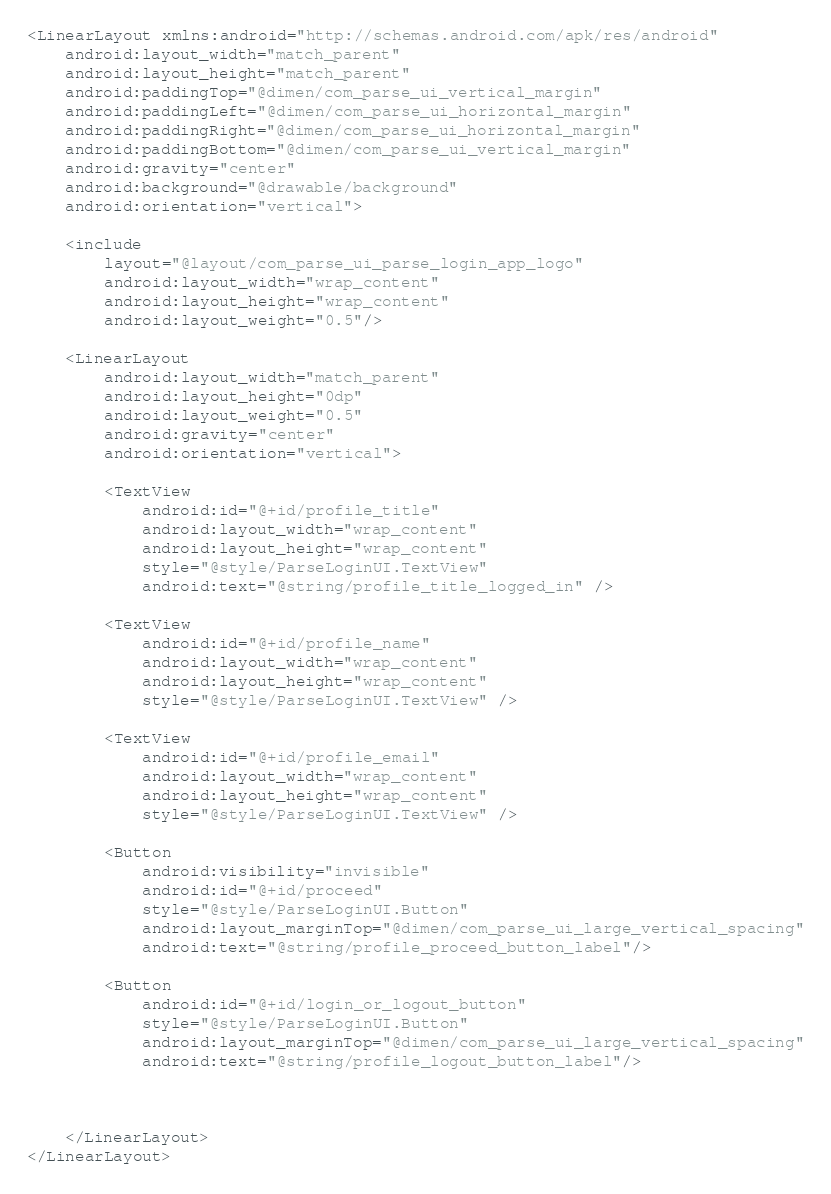Convert code to text. <code><loc_0><loc_0><loc_500><loc_500><_XML_><LinearLayout xmlns:android="http://schemas.android.com/apk/res/android"
    android:layout_width="match_parent"
    android:layout_height="match_parent"
    android:paddingTop="@dimen/com_parse_ui_vertical_margin"
    android:paddingLeft="@dimen/com_parse_ui_horizontal_margin"
    android:paddingRight="@dimen/com_parse_ui_horizontal_margin"
    android:paddingBottom="@dimen/com_parse_ui_vertical_margin"
    android:gravity="center"
    android:background="@drawable/background"
    android:orientation="vertical">

    <include
        layout="@layout/com_parse_ui_parse_login_app_logo"
        android:layout_width="wrap_content"
        android:layout_height="wrap_content"
        android:layout_weight="0.5"/>

    <LinearLayout
        android:layout_width="match_parent"
        android:layout_height="0dp"
        android:layout_weight="0.5"
        android:gravity="center"
        android:orientation="vertical">

        <TextView
            android:id="@+id/profile_title"
            android:layout_width="wrap_content"
            android:layout_height="wrap_content"
            style="@style/ParseLoginUI.TextView"
            android:text="@string/profile_title_logged_in" />

        <TextView
            android:id="@+id/profile_name"
            android:layout_width="wrap_content"
            android:layout_height="wrap_content"
            style="@style/ParseLoginUI.TextView" />

        <TextView
            android:id="@+id/profile_email"
            android:layout_width="wrap_content"
            android:layout_height="wrap_content"
            style="@style/ParseLoginUI.TextView" />

        <Button
            android:visibility="invisible"
            android:id="@+id/proceed"
            style="@style/ParseLoginUI.Button"
            android:layout_marginTop="@dimen/com_parse_ui_large_vertical_spacing"
            android:text="@string/profile_proceed_button_label"/>

        <Button
            android:id="@+id/login_or_logout_button"
            style="@style/ParseLoginUI.Button"
            android:layout_marginTop="@dimen/com_parse_ui_large_vertical_spacing"
            android:text="@string/profile_logout_button_label"/>



    </LinearLayout>
</LinearLayout>
</code> 